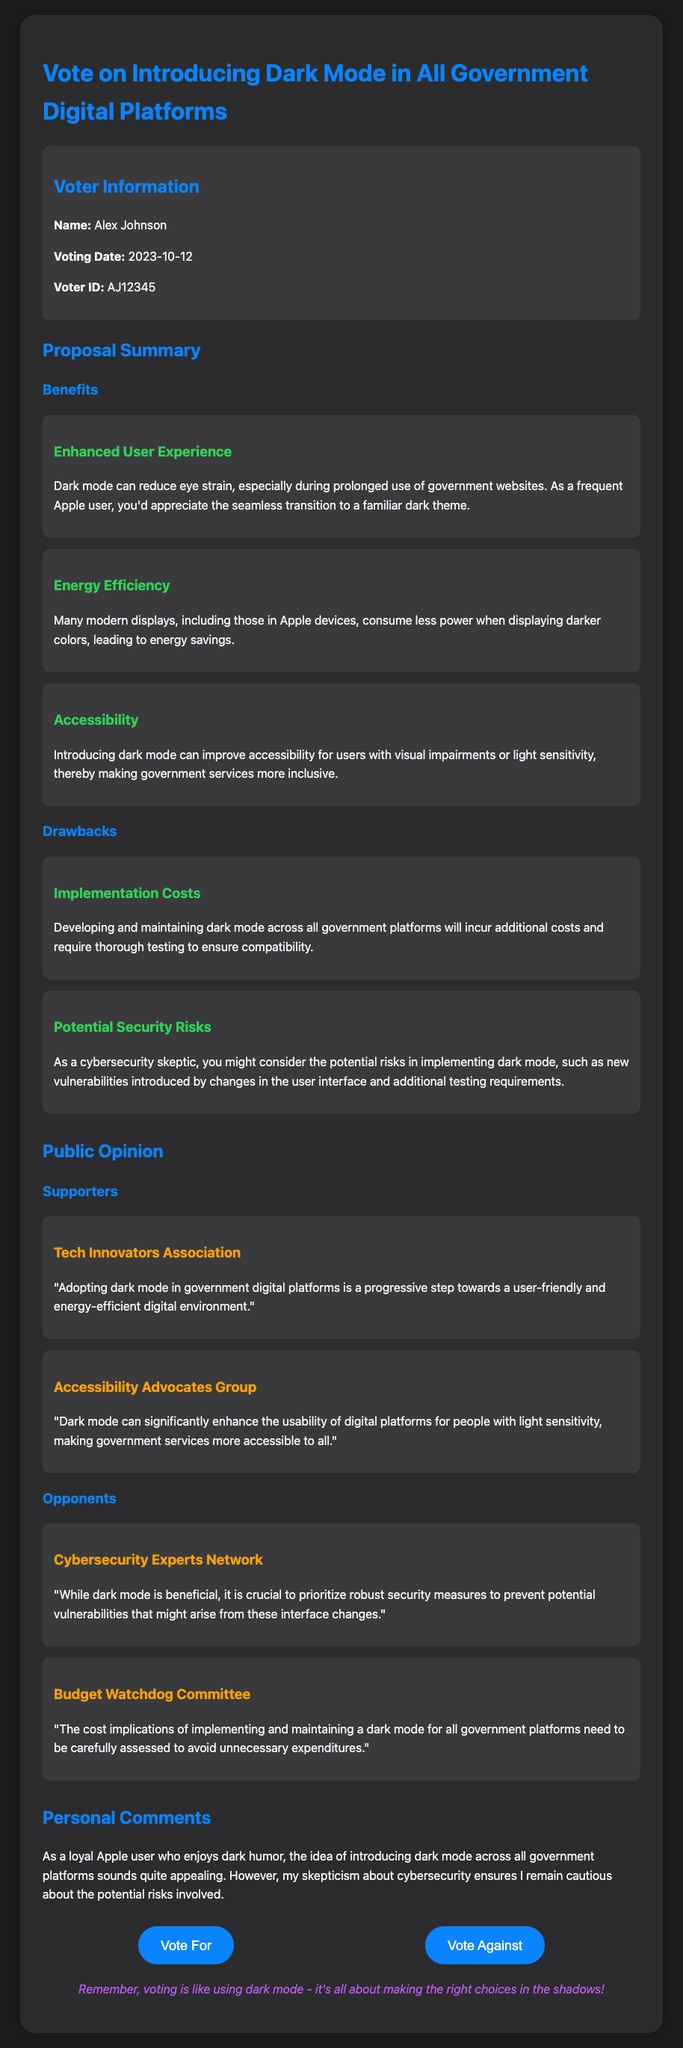What is the voter's name? The voter's name is provided in the voter information section of the document.
Answer: Alex Johnson What is the voting date? The voting date appears in the voter information section, indicating when the vote took place.
Answer: 2023-10-12 What is one of the benefits of introducing dark mode? The benefits are listed in the proposal summary; one specific benefit is the reduction of eye strain.
Answer: Enhanced User Experience What is one drawback mentioned regarding dark mode? The drawbacks are detailed in the proposal summary, which includes implementation costs.
Answer: Implementation Costs Who supports the adoption of dark mode? The supporters' section lists groups that advocate for dark mode, such as the Tech Innovators Association.
Answer: Tech Innovators Association What is a concern raised by the Cybersecurity Experts Network? The opponents’ section describes concerns raised by various groups about dark mode, particularly regarding security.
Answer: Potential vulnerabilities How does the document categorize public opinion? Public opinion is organized into two sections in the document: supporters and opponents.
Answer: Supporters and Opponents What does the personal comments section reflect? The personal comments express the voter's feelings about dark mode and any related concerns.
Answer: Skepticism about cybersecurity risks What kind of humor does the document reference? The document incorporates a type of humor related to dark themes and voting, emphasizing a playful tone.
Answer: Dark humor 